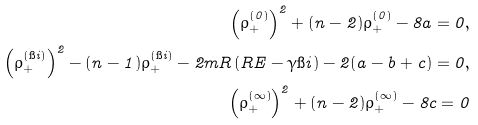<formula> <loc_0><loc_0><loc_500><loc_500>\left ( \rho ^ { ( 0 ) } _ { + } \right ) ^ { 2 } + ( n - 2 ) \rho ^ { ( 0 ) } _ { + } - 8 a = 0 , \\ \left ( \rho ^ { ( \i i ) } _ { + } \right ) ^ { 2 } - ( n - 1 ) \rho ^ { ( \i i ) } _ { + } - 2 m R \left ( R E - \gamma \i i \right ) - 2 ( a - b + c ) = 0 , \\ \left ( \rho ^ { ( \infty ) } _ { + } \right ) ^ { 2 } + ( n - 2 ) \rho ^ { ( \infty ) } _ { + } - 8 c = 0</formula> 